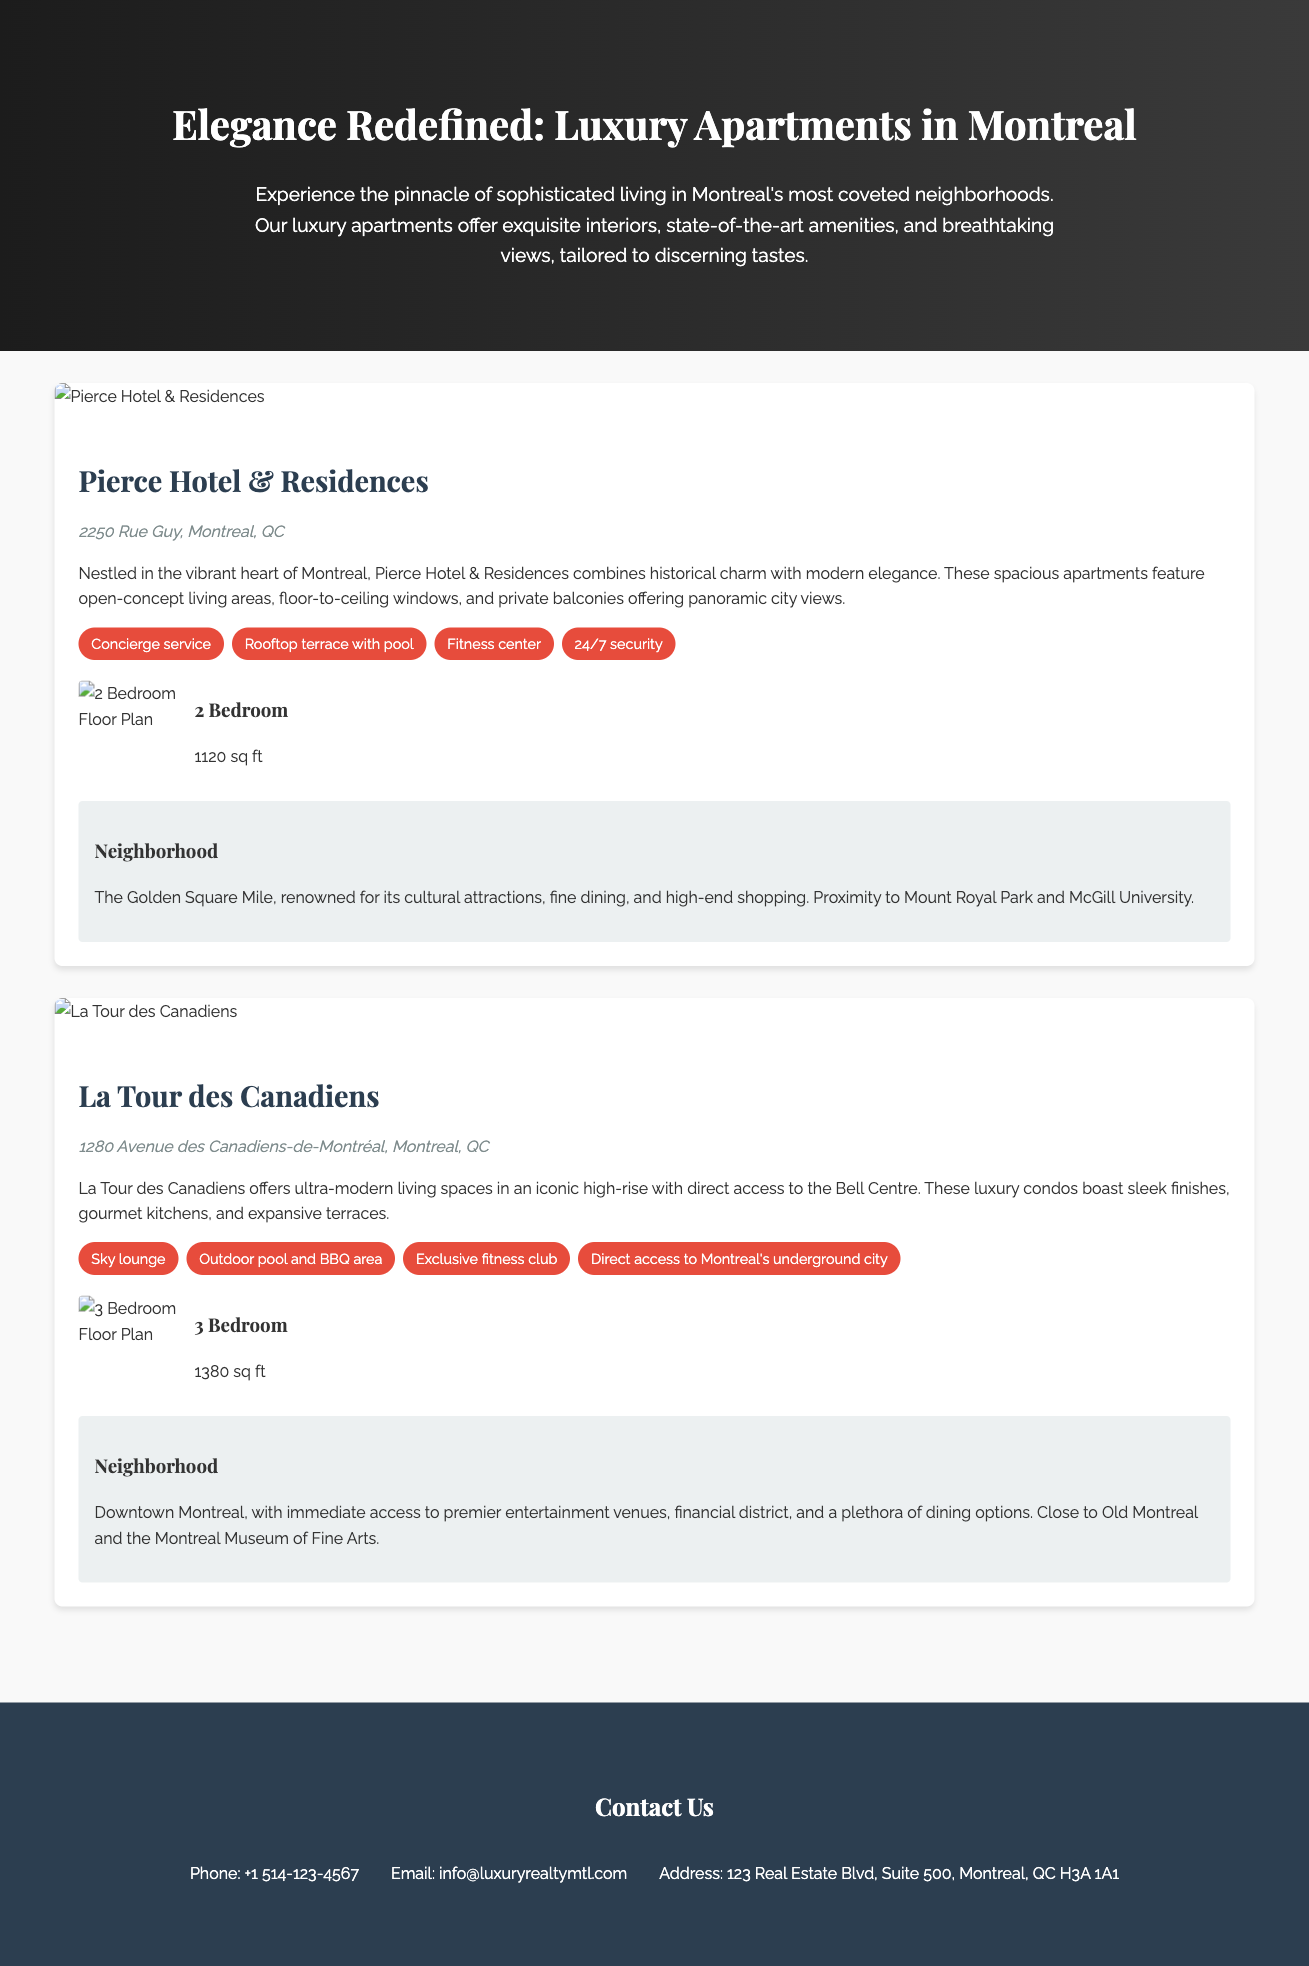What is the name of the first property listed? The first property listed in the document is named "Pierce Hotel & Residences."
Answer: Pierce Hotel & Residences What is the address of La Tour des Canadiens? The address of La Tour des Canadiens is clearly stated in the document as "1280 Avenue des Canadiens-de-Montréal, Montreal, QC."
Answer: 1280 Avenue des Canadiens-de-Montréal, Montreal, QC How many bedrooms are in the Pierce Hotel & Residences floor plan? The floor plan for Pierce Hotel & Residences indicates it has "2 Bedroom."
Answer: 2 Bedroom What is the size of the 3 Bedroom floor plan at La Tour des Canadiens? The size of the 3 Bedroom floor plan at La Tour des Canadiens is mentioned as "1380 sq ft."
Answer: 1380 sq ft What feature is highlighted for the outdoor area of La Tour des Canadiens? The document highlights the "Outdoor pool and BBQ area" as a feature for La Tour des Canadiens.
Answer: Outdoor pool and BBQ area Which neighborhood is associated with Pierce Hotel & Residences? The neighborhood associated with Pierce Hotel & Residences is "The Golden Square Mile."
Answer: The Golden Square Mile What is the contact phone number listed in the document? The contact phone number provided at the end of the document is "+1 514-123-4567."
Answer: +1 514-123-4567 Which service does Pierce Hotel & Residences offer? The document mentions "Concierge service" as one of the services offered by Pierce Hotel & Residences.
Answer: Concierge service What type of document is this? The document is a "Detailed Brochure for Luxury Apartment Listings."
Answer: Detailed Brochure for Luxury Apartment Listings 